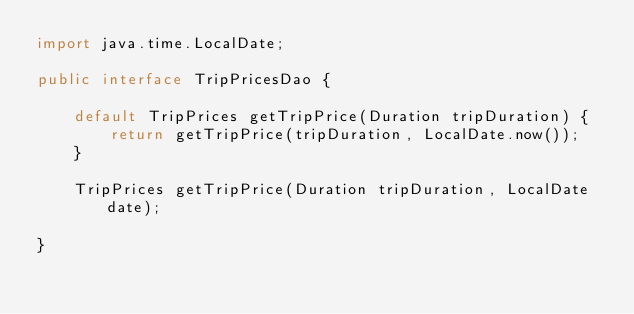<code> <loc_0><loc_0><loc_500><loc_500><_Java_>import java.time.LocalDate;

public interface TripPricesDao {

    default TripPrices getTripPrice(Duration tripDuration) {
        return getTripPrice(tripDuration, LocalDate.now());
    }

    TripPrices getTripPrice(Duration tripDuration, LocalDate date);

}
</code> 